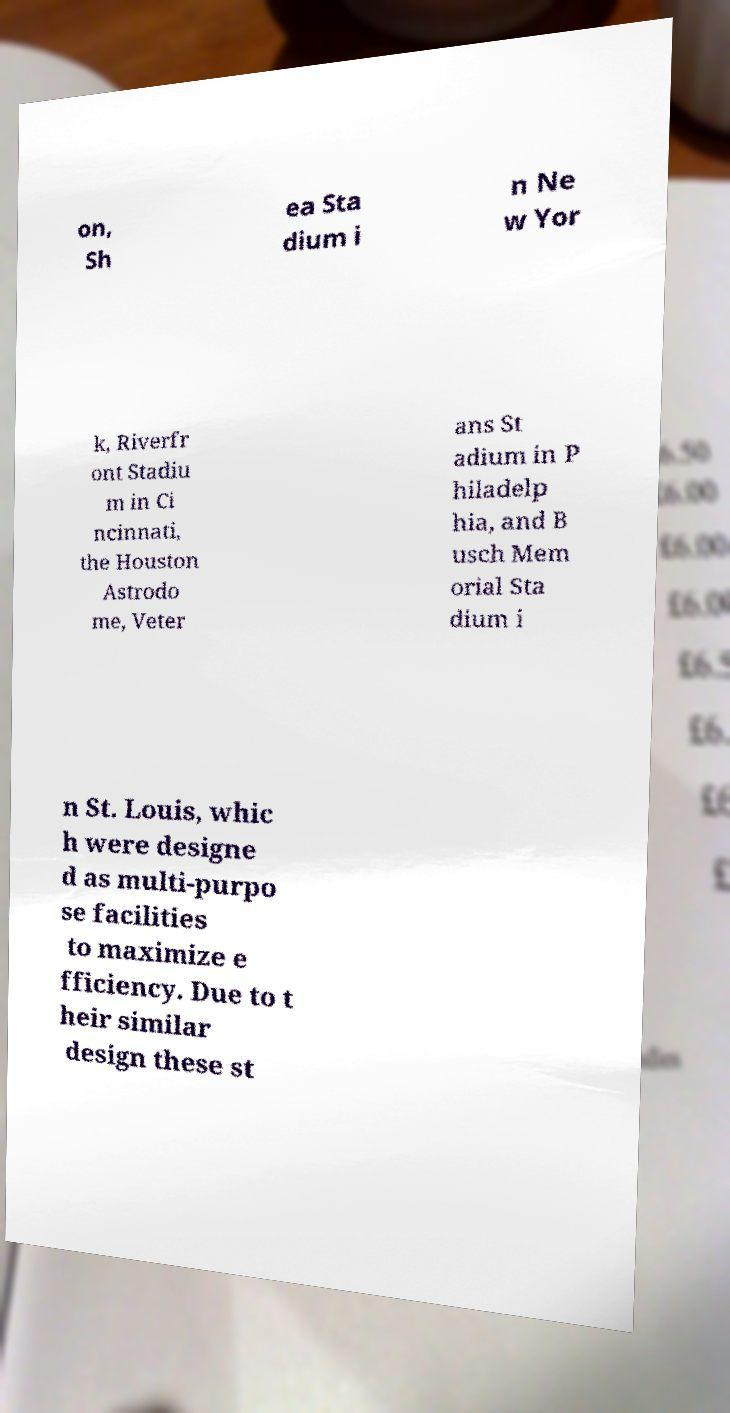For documentation purposes, I need the text within this image transcribed. Could you provide that? on, Sh ea Sta dium i n Ne w Yor k, Riverfr ont Stadiu m in Ci ncinnati, the Houston Astrodo me, Veter ans St adium in P hiladelp hia, and B usch Mem orial Sta dium i n St. Louis, whic h were designe d as multi-purpo se facilities to maximize e fficiency. Due to t heir similar design these st 